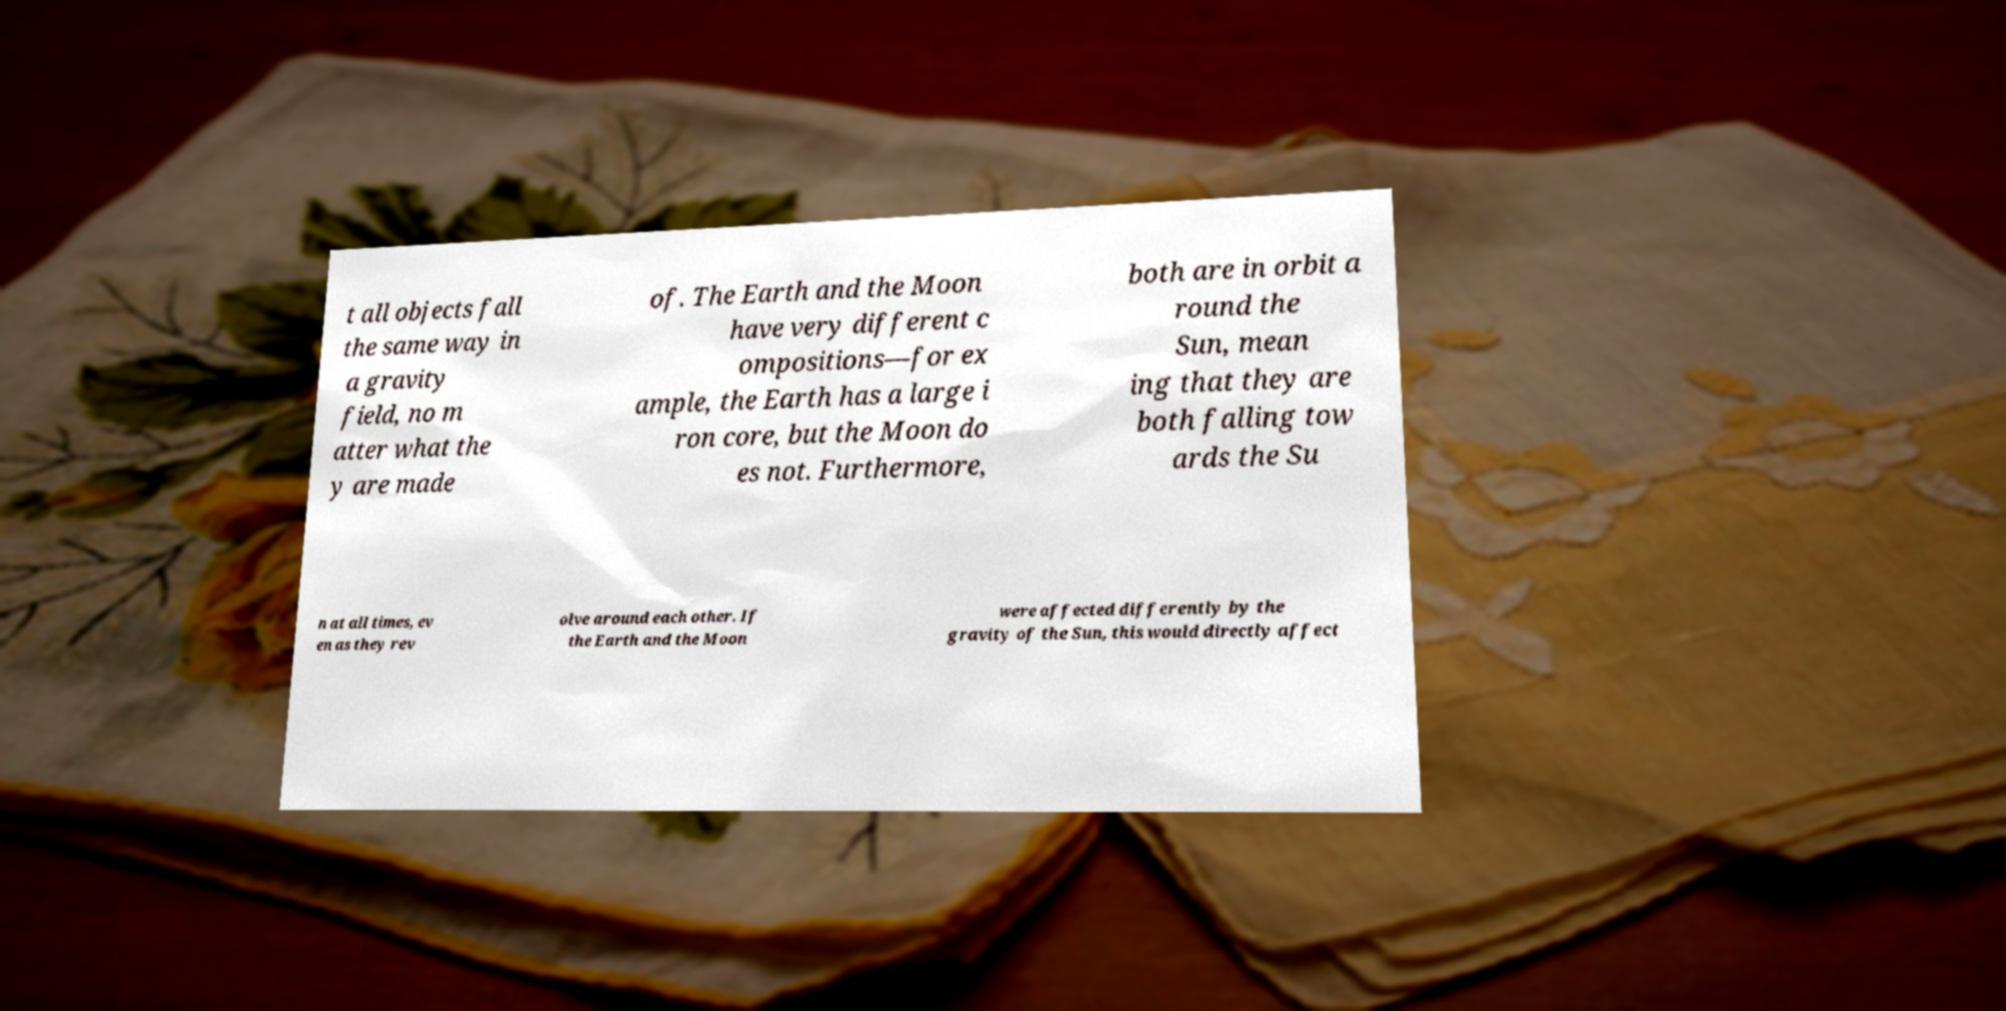I need the written content from this picture converted into text. Can you do that? t all objects fall the same way in a gravity field, no m atter what the y are made of. The Earth and the Moon have very different c ompositions—for ex ample, the Earth has a large i ron core, but the Moon do es not. Furthermore, both are in orbit a round the Sun, mean ing that they are both falling tow ards the Su n at all times, ev en as they rev olve around each other. If the Earth and the Moon were affected differently by the gravity of the Sun, this would directly affect 